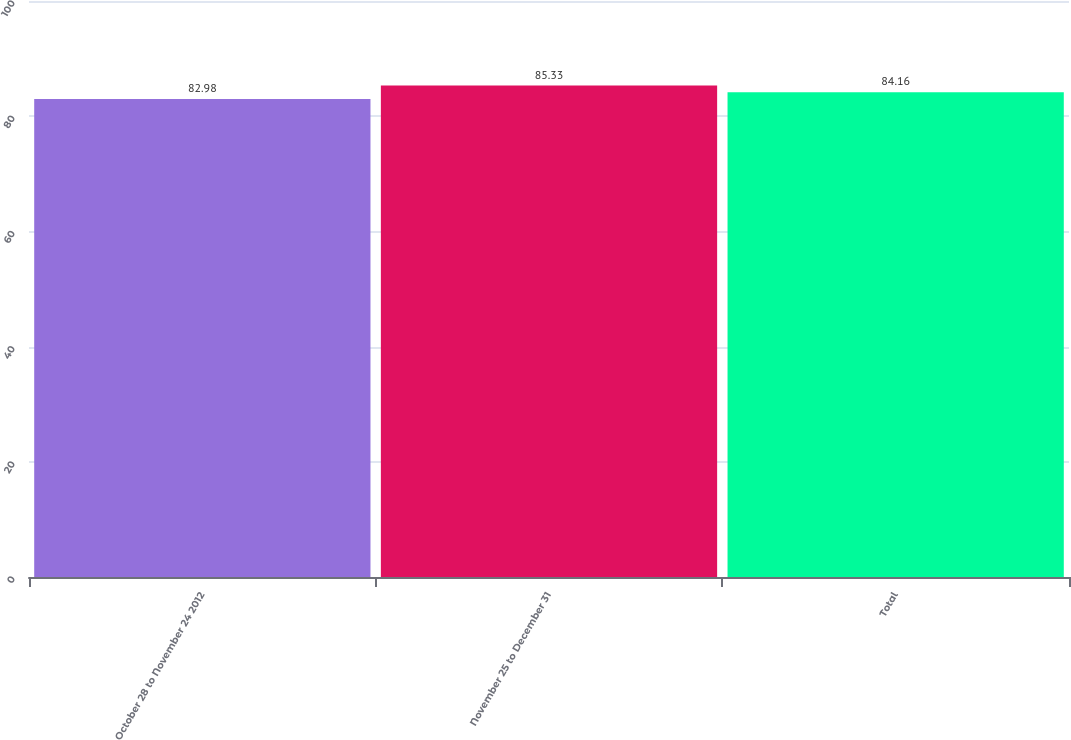<chart> <loc_0><loc_0><loc_500><loc_500><bar_chart><fcel>October 28 to November 24 2012<fcel>November 25 to December 31<fcel>Total<nl><fcel>82.98<fcel>85.33<fcel>84.16<nl></chart> 